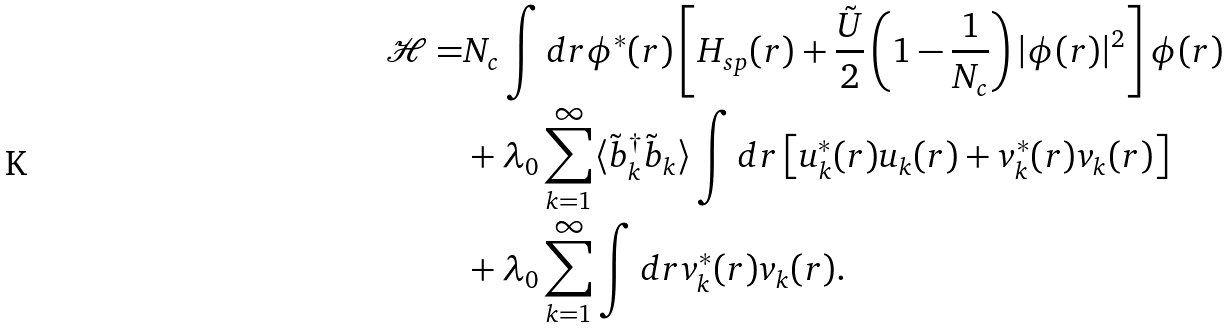<formula> <loc_0><loc_0><loc_500><loc_500>\mathcal { H } = & N _ { c } \int d r \phi ^ { * } ( r ) \left [ H _ { s p } ( r ) + \frac { \tilde { U } } { 2 } \left ( 1 - \frac { 1 } { N _ { c } } \right ) | \phi ( r ) | ^ { 2 } \right ] \phi ( r ) \\ & + \lambda _ { 0 } \sum _ { k = 1 } ^ { \infty } \langle \tilde { b } _ { k } ^ { \dagger } \tilde { b } _ { k } \rangle \int d r \left [ u _ { k } ^ { * } ( r ) u _ { k } ( r ) + v _ { k } ^ { * } ( r ) v _ { k } ( r ) \right ] \\ & + \lambda _ { 0 } \sum _ { k = 1 } ^ { \infty } \int d r v _ { k } ^ { * } ( r ) v _ { k } ( r ) .</formula> 